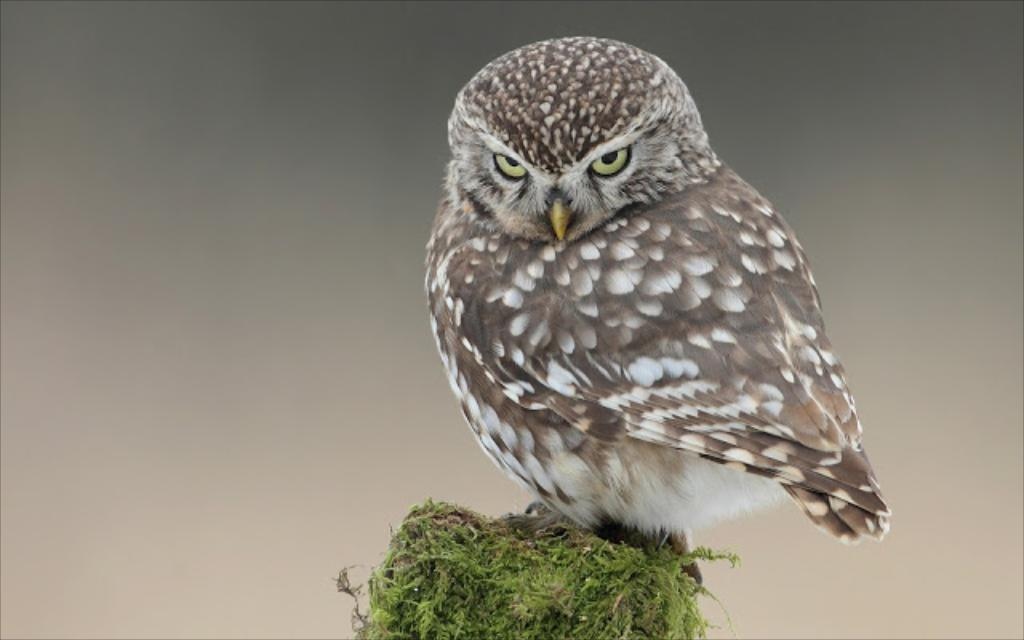What type of animal is in the picture? There is an owl in the picture. Can you describe the color of the owl? The owl is white and black in color. What type of division is being performed by the owl in the image? There is no division being performed by the owl in the image, as it is an animal and not a mathematical operation. 